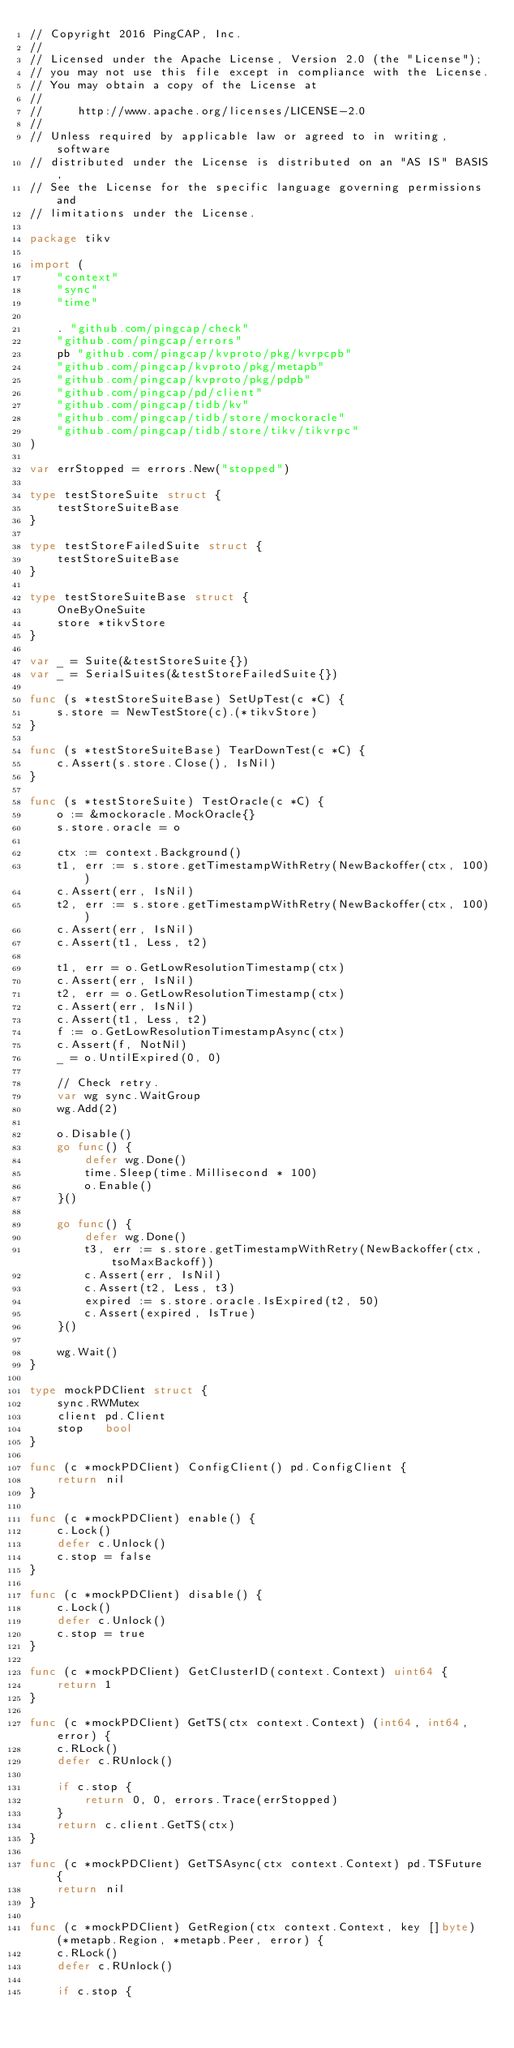Convert code to text. <code><loc_0><loc_0><loc_500><loc_500><_Go_>// Copyright 2016 PingCAP, Inc.
//
// Licensed under the Apache License, Version 2.0 (the "License");
// you may not use this file except in compliance with the License.
// You may obtain a copy of the License at
//
//     http://www.apache.org/licenses/LICENSE-2.0
//
// Unless required by applicable law or agreed to in writing, software
// distributed under the License is distributed on an "AS IS" BASIS,
// See the License for the specific language governing permissions and
// limitations under the License.

package tikv

import (
	"context"
	"sync"
	"time"

	. "github.com/pingcap/check"
	"github.com/pingcap/errors"
	pb "github.com/pingcap/kvproto/pkg/kvrpcpb"
	"github.com/pingcap/kvproto/pkg/metapb"
	"github.com/pingcap/kvproto/pkg/pdpb"
	"github.com/pingcap/pd/client"
	"github.com/pingcap/tidb/kv"
	"github.com/pingcap/tidb/store/mockoracle"
	"github.com/pingcap/tidb/store/tikv/tikvrpc"
)

var errStopped = errors.New("stopped")

type testStoreSuite struct {
	testStoreSuiteBase
}

type testStoreFailedSuite struct {
	testStoreSuiteBase
}

type testStoreSuiteBase struct {
	OneByOneSuite
	store *tikvStore
}

var _ = Suite(&testStoreSuite{})
var _ = SerialSuites(&testStoreFailedSuite{})

func (s *testStoreSuiteBase) SetUpTest(c *C) {
	s.store = NewTestStore(c).(*tikvStore)
}

func (s *testStoreSuiteBase) TearDownTest(c *C) {
	c.Assert(s.store.Close(), IsNil)
}

func (s *testStoreSuite) TestOracle(c *C) {
	o := &mockoracle.MockOracle{}
	s.store.oracle = o

	ctx := context.Background()
	t1, err := s.store.getTimestampWithRetry(NewBackoffer(ctx, 100))
	c.Assert(err, IsNil)
	t2, err := s.store.getTimestampWithRetry(NewBackoffer(ctx, 100))
	c.Assert(err, IsNil)
	c.Assert(t1, Less, t2)

	t1, err = o.GetLowResolutionTimestamp(ctx)
	c.Assert(err, IsNil)
	t2, err = o.GetLowResolutionTimestamp(ctx)
	c.Assert(err, IsNil)
	c.Assert(t1, Less, t2)
	f := o.GetLowResolutionTimestampAsync(ctx)
	c.Assert(f, NotNil)
	_ = o.UntilExpired(0, 0)

	// Check retry.
	var wg sync.WaitGroup
	wg.Add(2)

	o.Disable()
	go func() {
		defer wg.Done()
		time.Sleep(time.Millisecond * 100)
		o.Enable()
	}()

	go func() {
		defer wg.Done()
		t3, err := s.store.getTimestampWithRetry(NewBackoffer(ctx, tsoMaxBackoff))
		c.Assert(err, IsNil)
		c.Assert(t2, Less, t3)
		expired := s.store.oracle.IsExpired(t2, 50)
		c.Assert(expired, IsTrue)
	}()

	wg.Wait()
}

type mockPDClient struct {
	sync.RWMutex
	client pd.Client
	stop   bool
}

func (c *mockPDClient) ConfigClient() pd.ConfigClient {
	return nil
}

func (c *mockPDClient) enable() {
	c.Lock()
	defer c.Unlock()
	c.stop = false
}

func (c *mockPDClient) disable() {
	c.Lock()
	defer c.Unlock()
	c.stop = true
}

func (c *mockPDClient) GetClusterID(context.Context) uint64 {
	return 1
}

func (c *mockPDClient) GetTS(ctx context.Context) (int64, int64, error) {
	c.RLock()
	defer c.RUnlock()

	if c.stop {
		return 0, 0, errors.Trace(errStopped)
	}
	return c.client.GetTS(ctx)
}

func (c *mockPDClient) GetTSAsync(ctx context.Context) pd.TSFuture {
	return nil
}

func (c *mockPDClient) GetRegion(ctx context.Context, key []byte) (*metapb.Region, *metapb.Peer, error) {
	c.RLock()
	defer c.RUnlock()

	if c.stop {</code> 